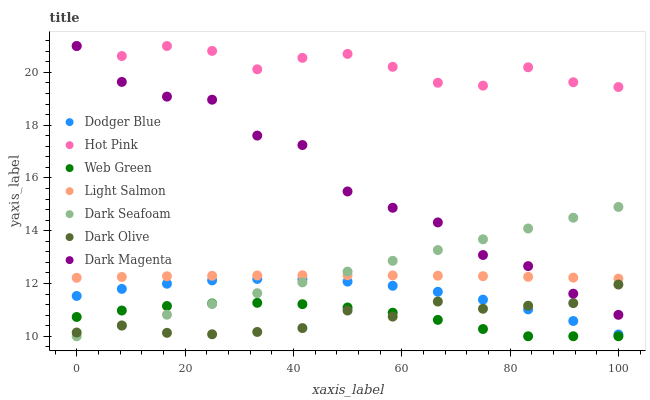Does Dark Olive have the minimum area under the curve?
Answer yes or no. Yes. Does Hot Pink have the maximum area under the curve?
Answer yes or no. Yes. Does Dark Magenta have the minimum area under the curve?
Answer yes or no. No. Does Dark Magenta have the maximum area under the curve?
Answer yes or no. No. Is Dark Seafoam the smoothest?
Answer yes or no. Yes. Is Dark Magenta the roughest?
Answer yes or no. Yes. Is Hot Pink the smoothest?
Answer yes or no. No. Is Hot Pink the roughest?
Answer yes or no. No. Does Web Green have the lowest value?
Answer yes or no. Yes. Does Dark Magenta have the lowest value?
Answer yes or no. No. Does Dark Magenta have the highest value?
Answer yes or no. Yes. Does Dark Olive have the highest value?
Answer yes or no. No. Is Dark Seafoam less than Hot Pink?
Answer yes or no. Yes. Is Light Salmon greater than Dark Olive?
Answer yes or no. Yes. Does Dark Seafoam intersect Dark Magenta?
Answer yes or no. Yes. Is Dark Seafoam less than Dark Magenta?
Answer yes or no. No. Is Dark Seafoam greater than Dark Magenta?
Answer yes or no. No. Does Dark Seafoam intersect Hot Pink?
Answer yes or no. No. 